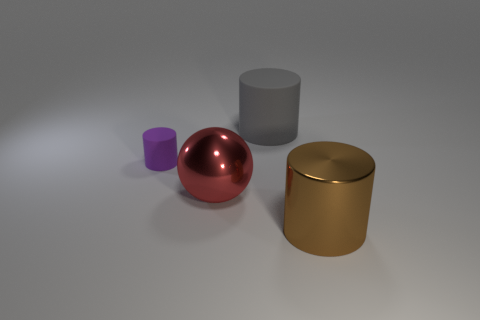Are there any reflections visible on the objects that give a clue to the light source? Indeed, the objects have subtle highlights and shadows that suggest a light source positioned above them, slightly off-center. The red sphere and the golden canister show reflections and gradients that imply a diffused light in the environment. 